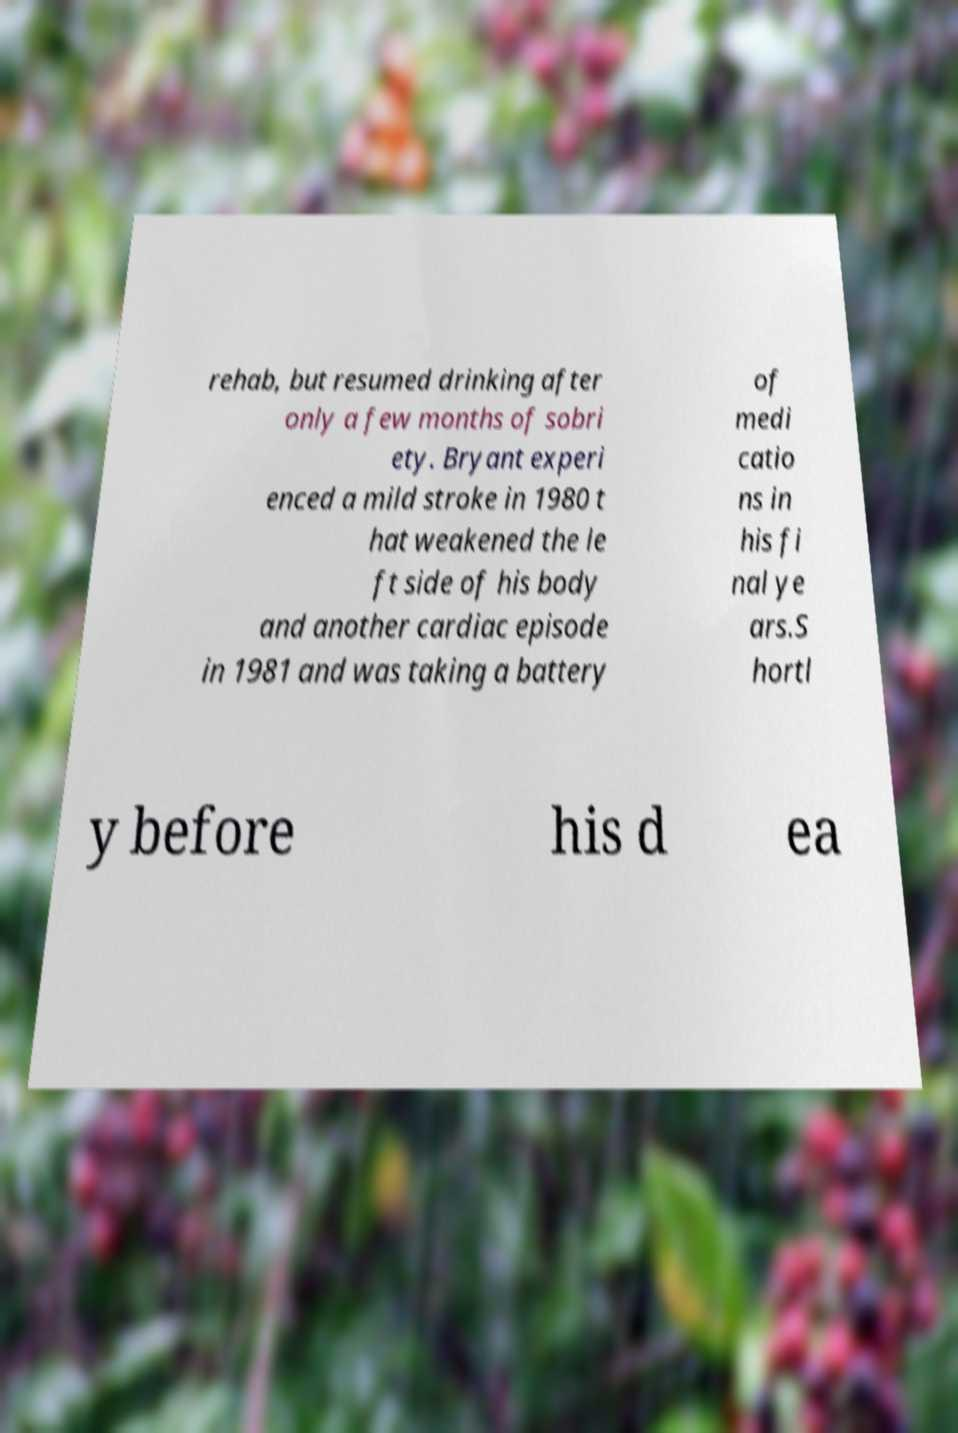Can you accurately transcribe the text from the provided image for me? rehab, but resumed drinking after only a few months of sobri ety. Bryant experi enced a mild stroke in 1980 t hat weakened the le ft side of his body and another cardiac episode in 1981 and was taking a battery of medi catio ns in his fi nal ye ars.S hortl y before his d ea 